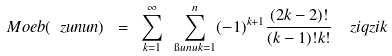Convert formula to latex. <formula><loc_0><loc_0><loc_500><loc_500>M o e b ( \ z u n u n ) \ = \ \sum _ { k = 1 } ^ { \infty } \ \sum _ { \i u n u k = 1 } ^ { n } ( - 1 ) ^ { k + 1 } \frac { ( 2 k - 2 ) ! } { ( k - 1 ) ! k ! } \ \ z i q z i k</formula> 